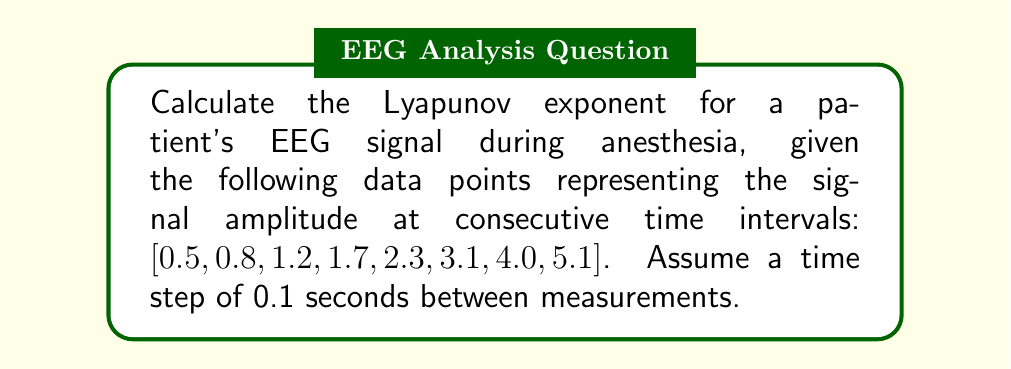Give your solution to this math problem. To calculate the Lyapunov exponent for the given EEG signal, we'll follow these steps:

1. Calculate the differences between consecutive data points:
   $$\Delta y_i = y_{i+1} - y_i$$
   [0.3, 0.4, 0.5, 0.6, 0.8, 0.9, 1.1]

2. Calculate the logarithm of the absolute values of these differences:
   $$\ln |\Delta y_i|$$
   [-1.204, -0.916, -0.693, -0.511, -0.223, -0.105, 0.095]

3. Calculate the average of these logarithms:
   $$\lambda_{est} = \frac{1}{N-1} \sum_{i=1}^{N-1} \ln |\Delta y_i|$$
   where N is the number of data points.
   
   $$\lambda_{est} = \frac{1}{7} (-3.557) = -0.508$$

4. Divide by the time step to get the Lyapunov exponent:
   $$\lambda = \frac{\lambda_{est}}{\Delta t} = \frac{-0.508}{0.1} = -5.08$$

The negative Lyapunov exponent indicates that the system is converging, which is consistent with the stabilizing effect of anesthesia on brain activity.
Answer: $-5.08$ $s^{-1}$ 